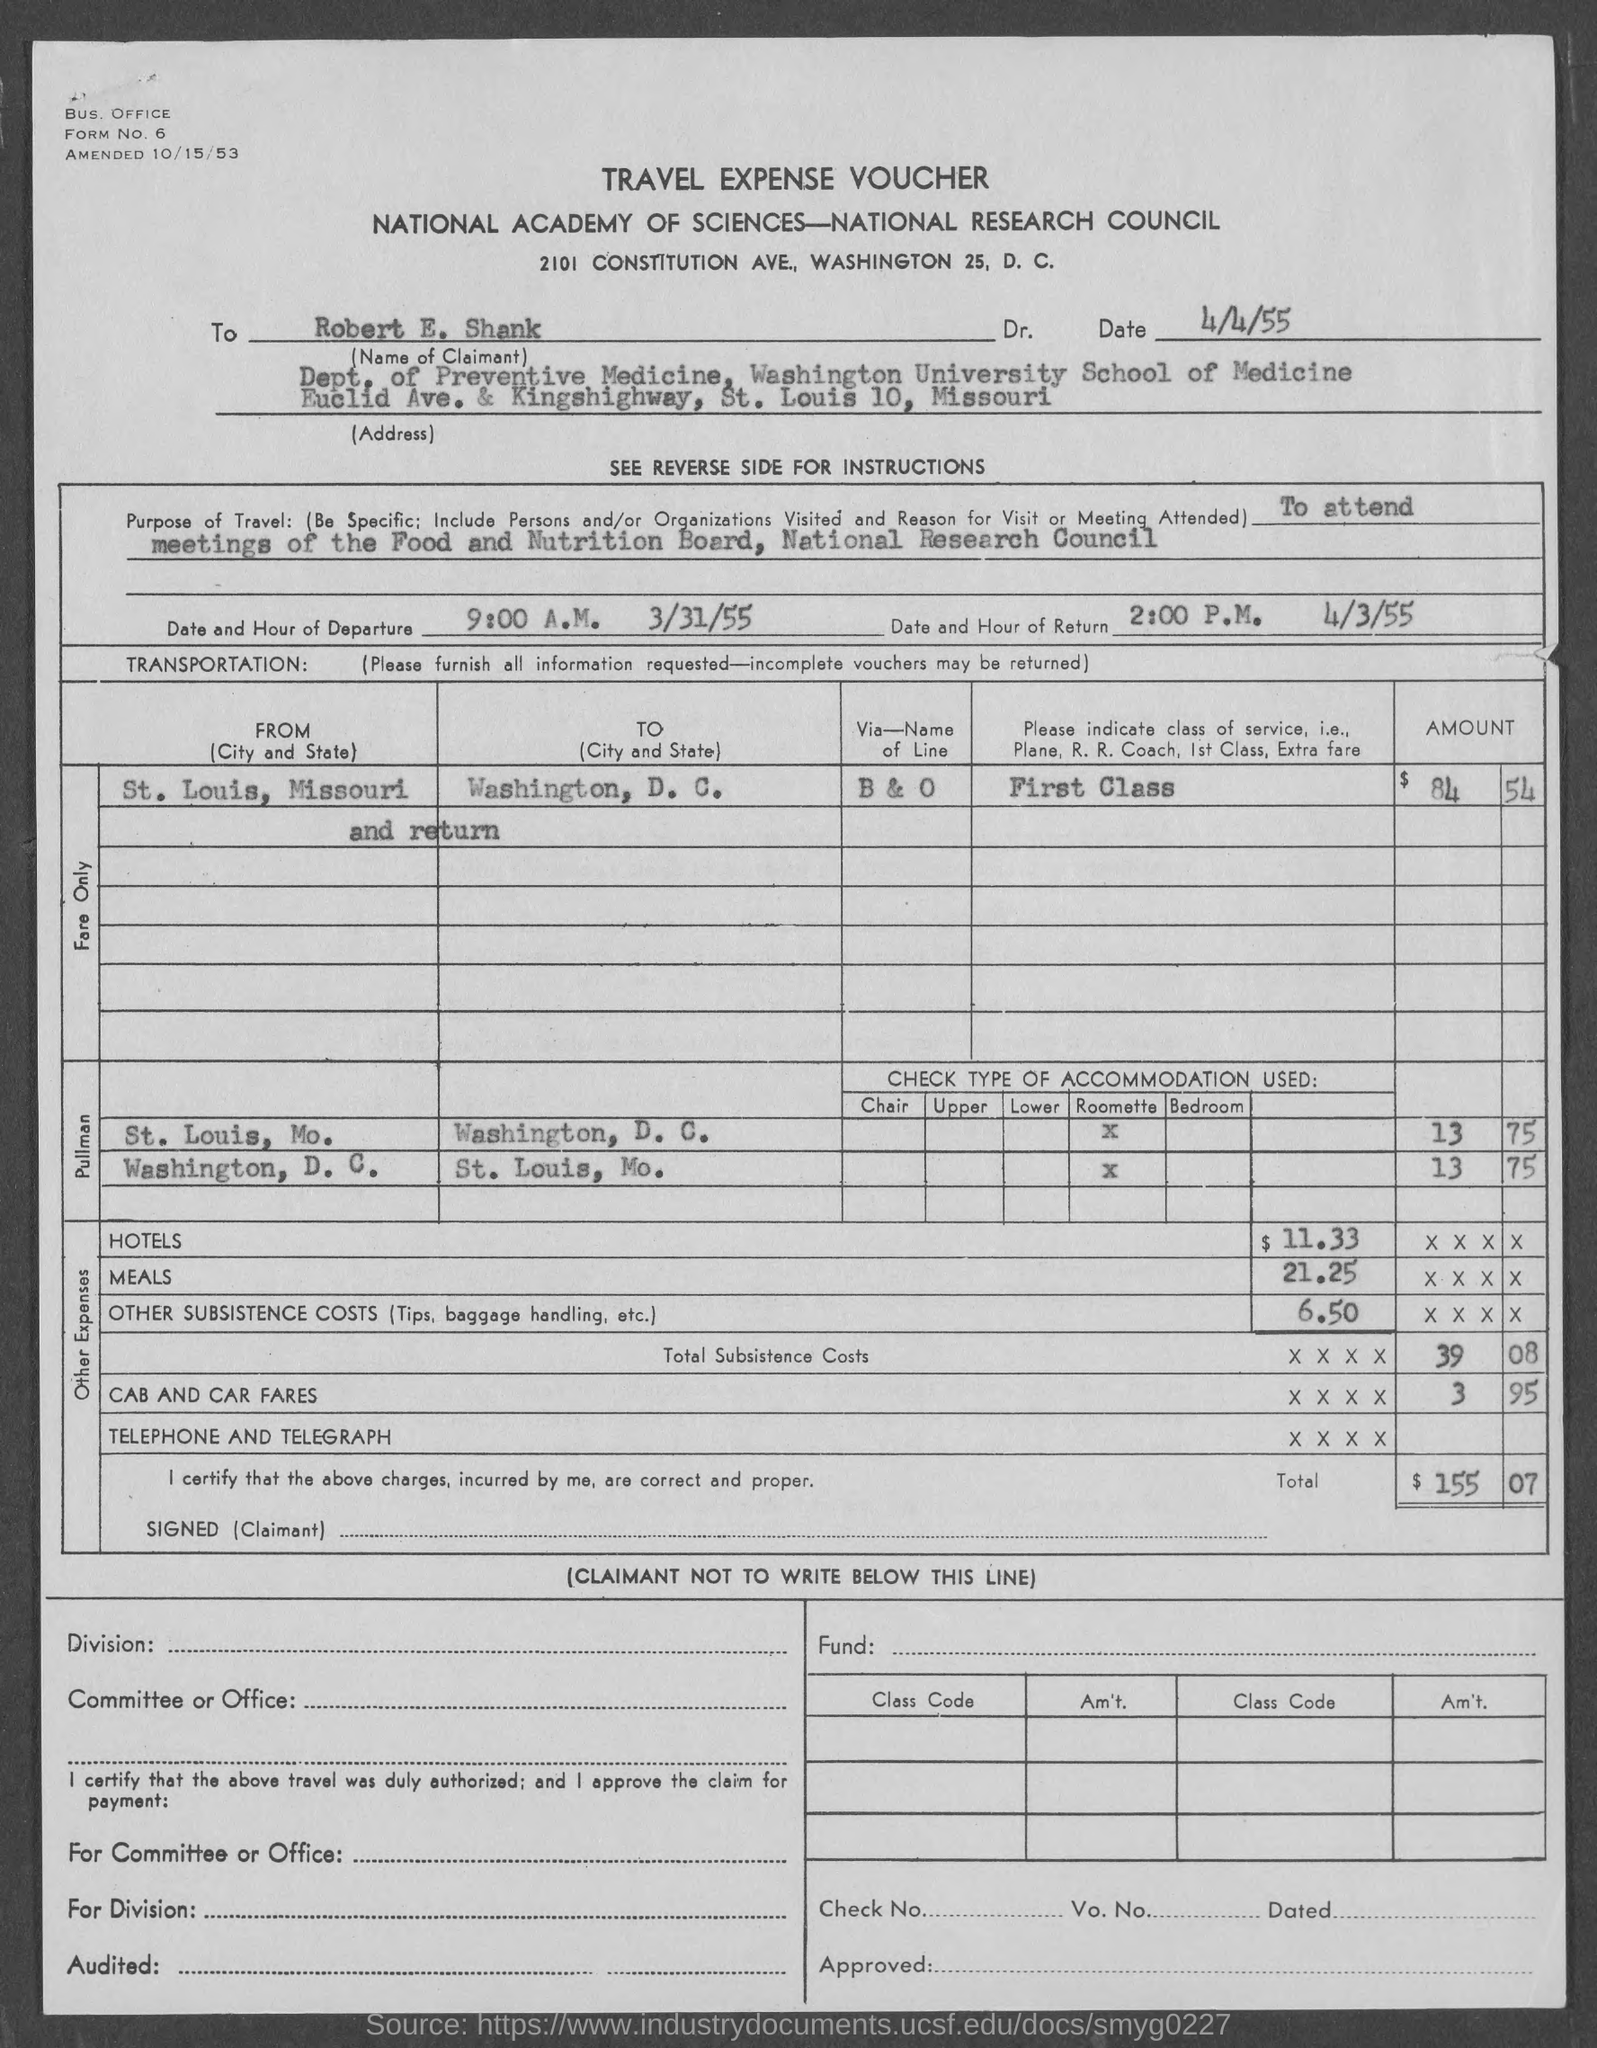Highlight a few significant elements in this photo. What is the form number?" "It is 6.. The date of return is April 3, 1955. The hour of departure is 9:00 A.M. The hour of return is 2:00 P.M. The date of departure is March 31st, 1955. 